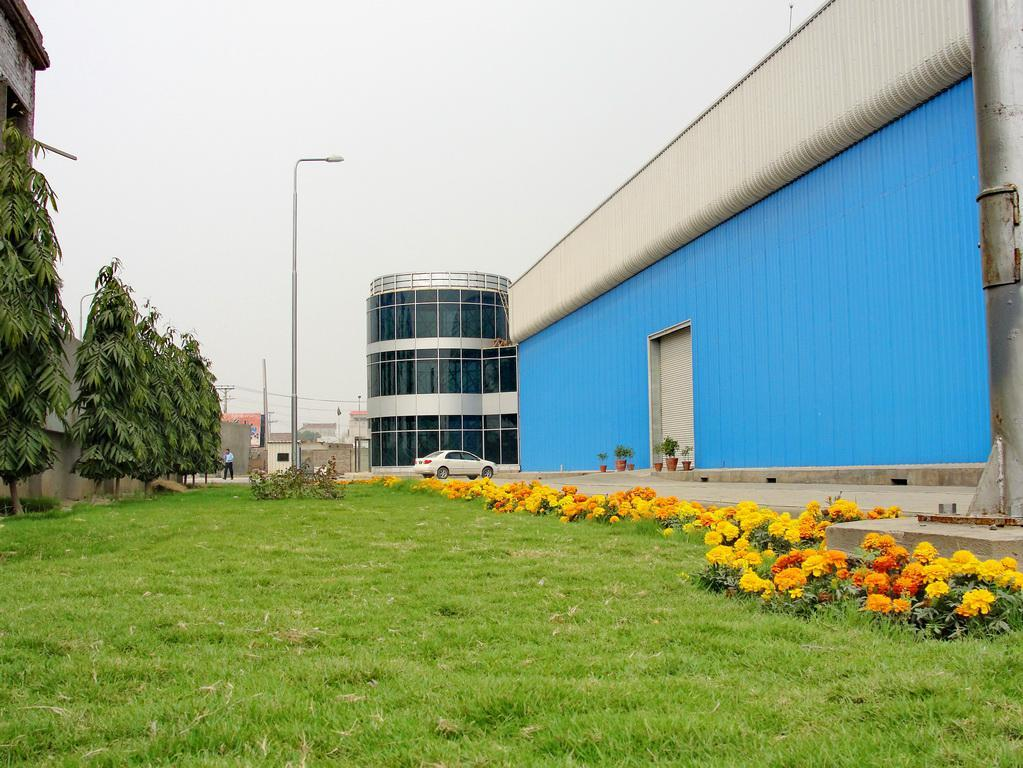What type of structures can be seen in the image? There are buildings in the image. What natural elements are present in the image? There are trees and plants in the image. What type of animal is in the image? There is a cat in the image. Are there any human figures in the image? Yes, there is a person in the image. What are the poles used for in the image? The purpose of the poles is not specified, but they are visible in the image. What type of rock is the band playing on in the image? There is no rock or band present in the image. Can you provide an example of a plant that is not visible in the image? It is not necessary to provide an example of a plant that is not visible in the image, as the facts provided only mention the plants that are present. 